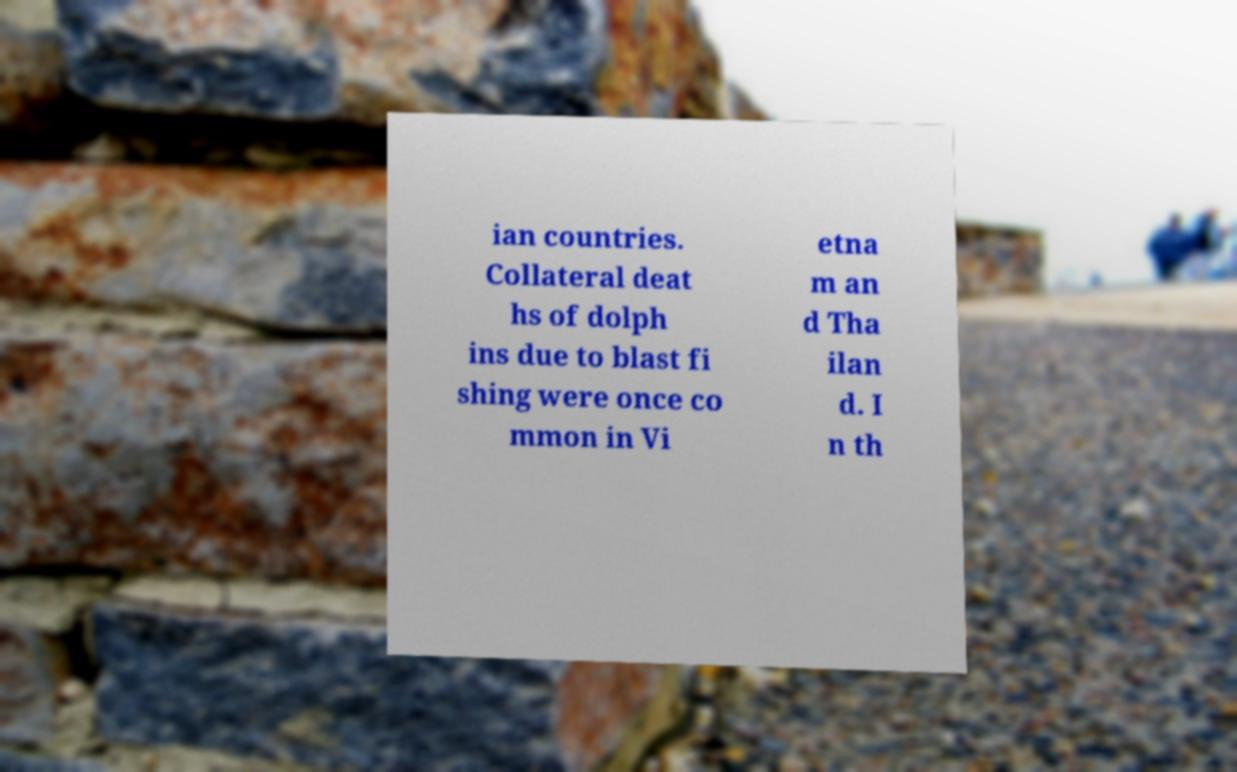There's text embedded in this image that I need extracted. Can you transcribe it verbatim? ian countries. Collateral deat hs of dolph ins due to blast fi shing were once co mmon in Vi etna m an d Tha ilan d. I n th 